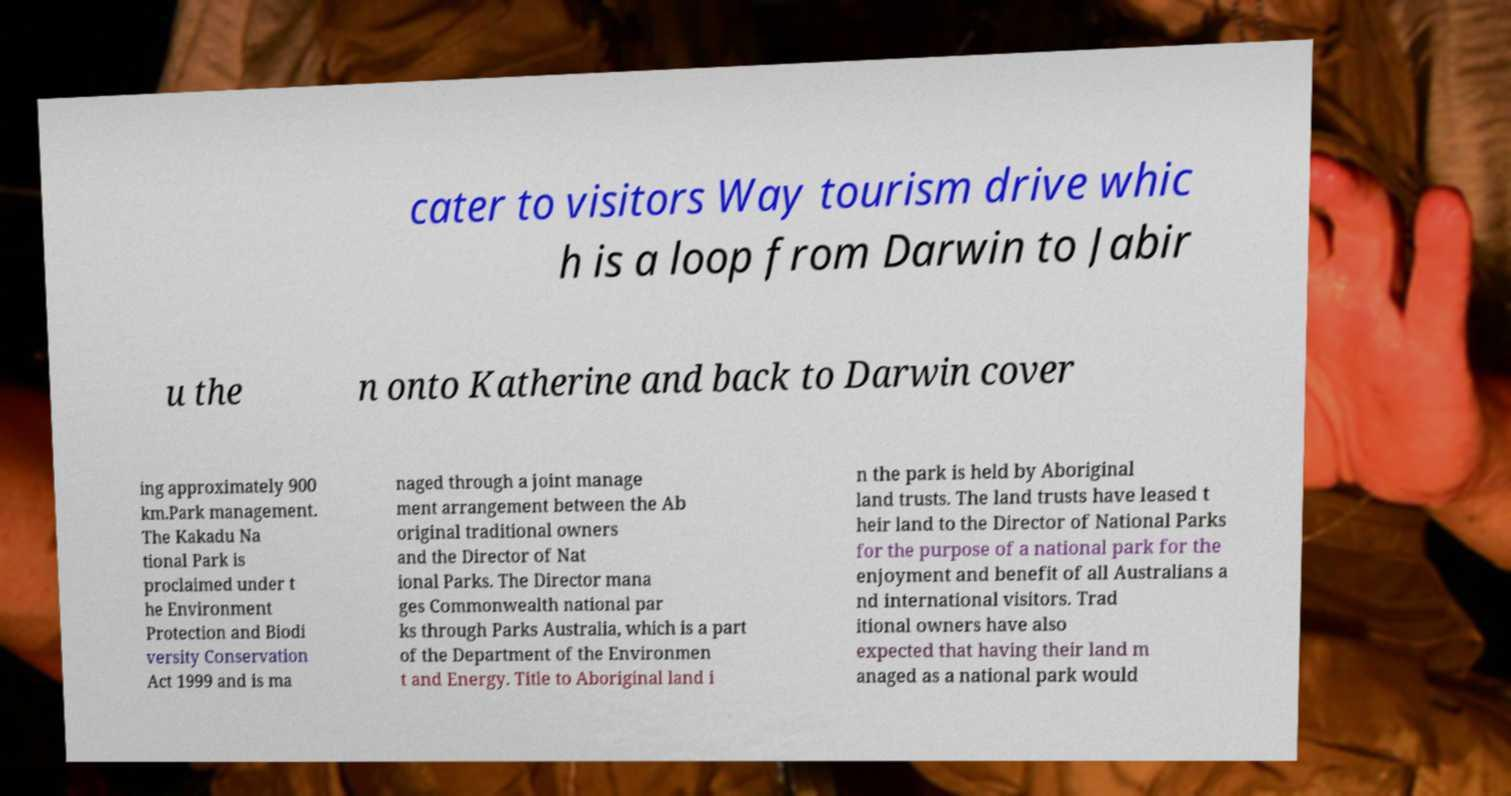Could you extract and type out the text from this image? cater to visitors Way tourism drive whic h is a loop from Darwin to Jabir u the n onto Katherine and back to Darwin cover ing approximately 900 km.Park management. The Kakadu Na tional Park is proclaimed under t he Environment Protection and Biodi versity Conservation Act 1999 and is ma naged through a joint manage ment arrangement between the Ab original traditional owners and the Director of Nat ional Parks. The Director mana ges Commonwealth national par ks through Parks Australia, which is a part of the Department of the Environmen t and Energy. Title to Aboriginal land i n the park is held by Aboriginal land trusts. The land trusts have leased t heir land to the Director of National Parks for the purpose of a national park for the enjoyment and benefit of all Australians a nd international visitors. Trad itional owners have also expected that having their land m anaged as a national park would 